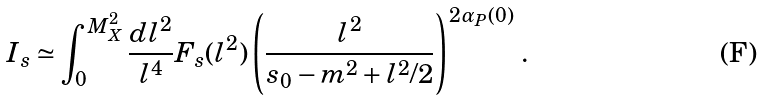Convert formula to latex. <formula><loc_0><loc_0><loc_500><loc_500>I _ { s } \simeq \int _ { 0 } ^ { M _ { X } ^ { 2 } } \frac { d l ^ { 2 } } { l ^ { 4 } } F _ { s } ( l ^ { 2 } ) \left ( \frac { l ^ { 2 } } { s _ { 0 } - m ^ { 2 } + l ^ { 2 } / 2 } \right ) ^ { 2 \alpha _ { P } ( 0 ) } \, .</formula> 